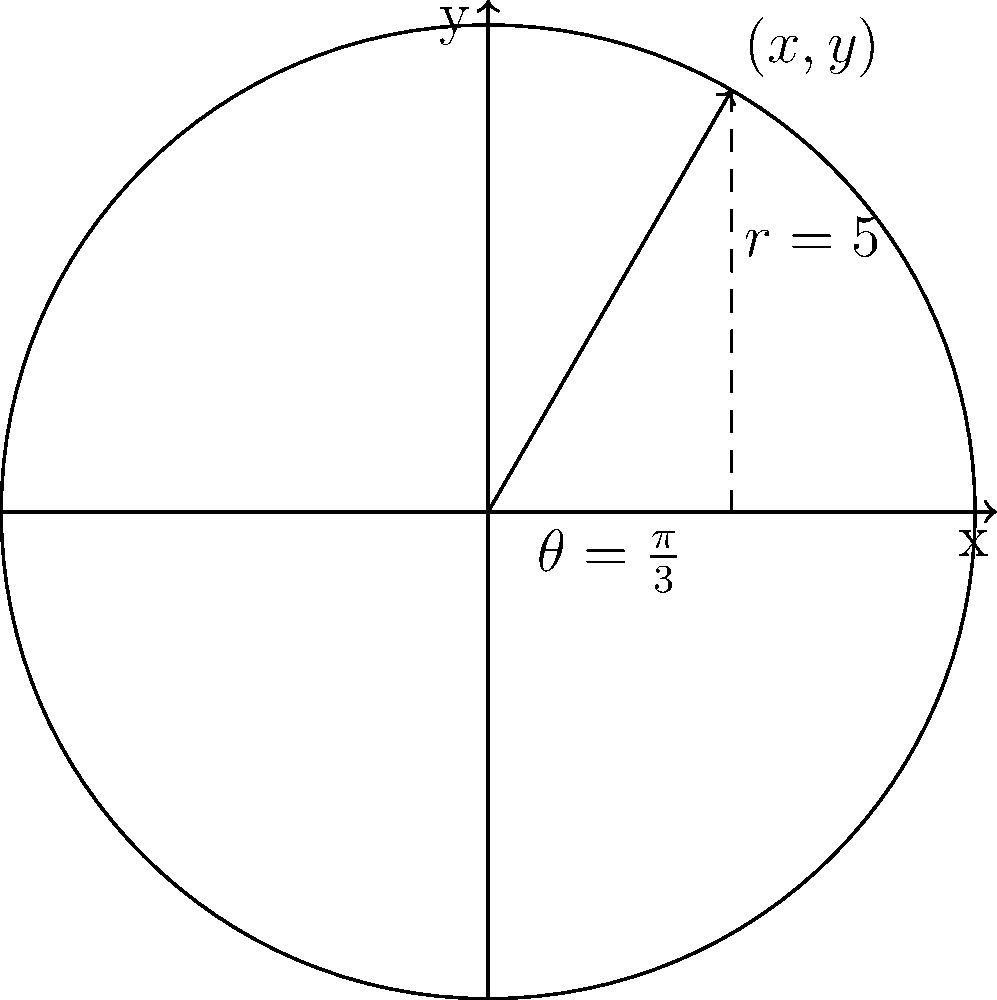As a service technician, you need to position a piece of equipment precisely using polar coordinates. Given the polar coordinates $(r,\theta) = (5,\frac{\pi}{3})$, calculate the rectangular coordinates $(x,y)$ for accurate placement. Round your answer to two decimal places. To convert polar coordinates $(r,\theta)$ to rectangular coordinates $(x,y)$, we use these formulas:

1) $x = r \cos(\theta)$
2) $y = r \sin(\theta)$

Given: $r = 5$ and $\theta = \frac{\pi}{3}$

Step 1: Calculate x
$x = 5 \cos(\frac{\pi}{3})$
$\cos(\frac{\pi}{3}) = 0.5$
$x = 5 \cdot 0.5 = 2.5$

Step 2: Calculate y
$y = 5 \sin(\frac{\pi}{3})$
$\sin(\frac{\pi}{3}) = \frac{\sqrt{3}}{2} \approx 0.866$
$y = 5 \cdot 0.866 = 4.33$

Step 3: Round to two decimal places
$x = 2.50$
$y = 4.33$

Therefore, the rectangular coordinates are $(2.50, 4.33)$.
Answer: $(2.50, 4.33)$ 